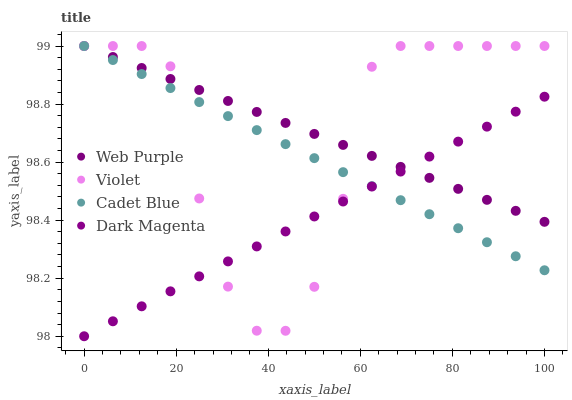Does Dark Magenta have the minimum area under the curve?
Answer yes or no. Yes. Does Violet have the maximum area under the curve?
Answer yes or no. Yes. Does Cadet Blue have the minimum area under the curve?
Answer yes or no. No. Does Cadet Blue have the maximum area under the curve?
Answer yes or no. No. Is Cadet Blue the smoothest?
Answer yes or no. Yes. Is Violet the roughest?
Answer yes or no. Yes. Is Dark Magenta the smoothest?
Answer yes or no. No. Is Dark Magenta the roughest?
Answer yes or no. No. Does Dark Magenta have the lowest value?
Answer yes or no. Yes. Does Cadet Blue have the lowest value?
Answer yes or no. No. Does Violet have the highest value?
Answer yes or no. Yes. Does Dark Magenta have the highest value?
Answer yes or no. No. Does Dark Magenta intersect Cadet Blue?
Answer yes or no. Yes. Is Dark Magenta less than Cadet Blue?
Answer yes or no. No. Is Dark Magenta greater than Cadet Blue?
Answer yes or no. No. 